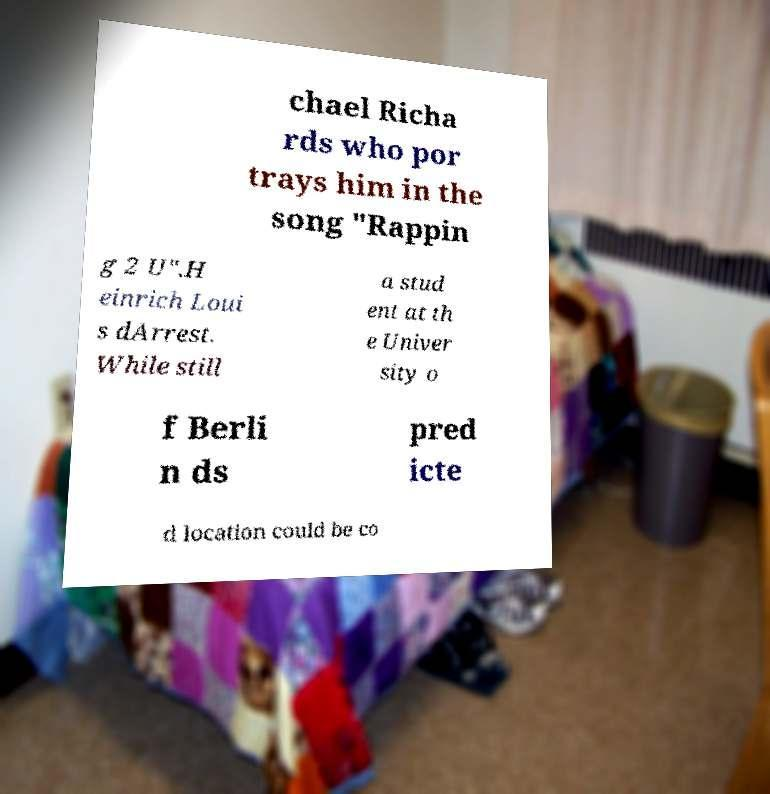I need the written content from this picture converted into text. Can you do that? chael Richa rds who por trays him in the song "Rappin g 2 U".H einrich Loui s dArrest. While still a stud ent at th e Univer sity o f Berli n ds pred icte d location could be co 